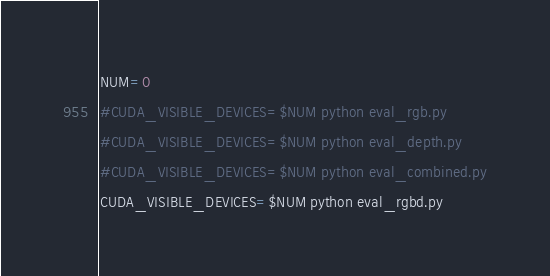<code> <loc_0><loc_0><loc_500><loc_500><_Bash_>NUM=0
#CUDA_VISIBLE_DEVICES=$NUM python eval_rgb.py
#CUDA_VISIBLE_DEVICES=$NUM python eval_depth.py
#CUDA_VISIBLE_DEVICES=$NUM python eval_combined.py
CUDA_VISIBLE_DEVICES=$NUM python eval_rgbd.py

</code> 